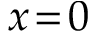<formula> <loc_0><loc_0><loc_500><loc_500>x \, = \, 0</formula> 